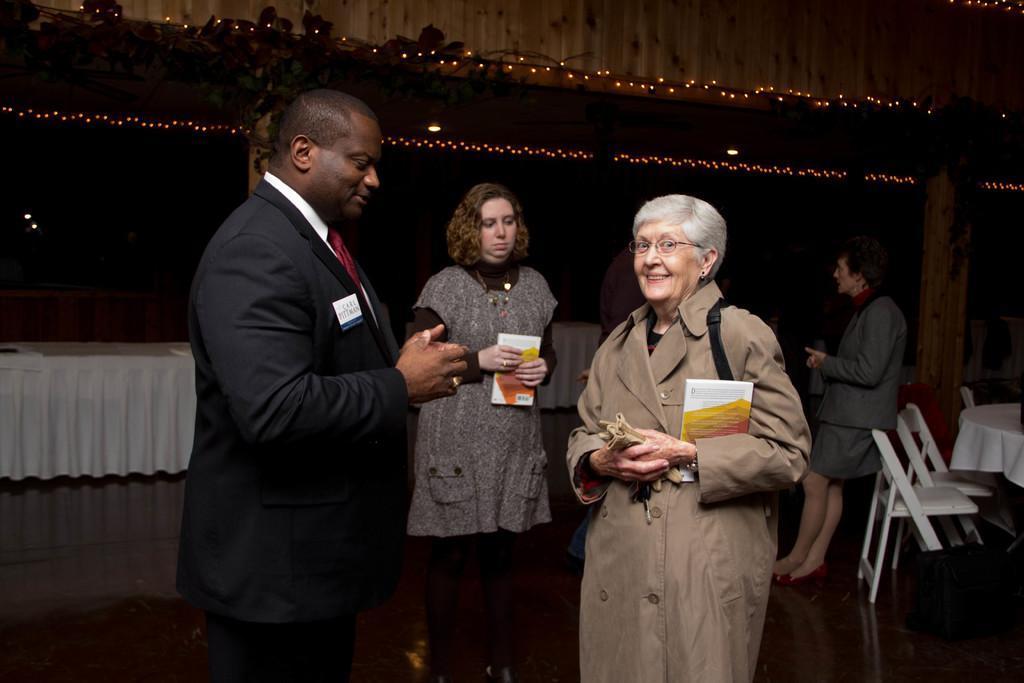In one or two sentences, can you explain what this image depicts? In the foreground of the picture I can see two persons and looks like they are having a conversation. There is a man on the left side is wearing a suit and a tie. I can see a woman on the right side is holding a book and there is a smile on her face. I can see another woman in the middle of the image and she is also holding a book. I can see a woman on the right side and looks like she is speaking to a person. I can see the tables and chairs on the floor. I can see the lighting arrangement at the top of the picture. 